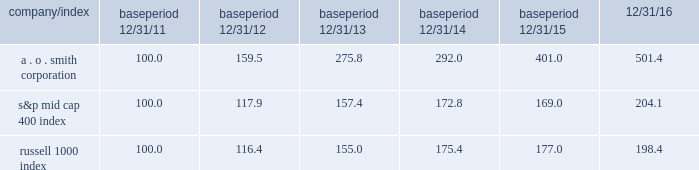The graph below shows a five-year comparison of the cumulative shareholder return on our common stock with the cumulative total return of the standard & poor 2019s ( s&p ) mid cap 400 index and the russell 1000 index , both of which are published indices .
Comparison of five-year cumulative total return from december 31 , 2011 to december 31 , 2016 assumes $ 100 invested with reinvestment of dividends period indexed returns .
2011 2012 2013 2014 2015 2016 smith ( a o ) corp s&p midcap 400 index russell 1000 index .
What was the difference in total return for the five year period ended 12/31/16 between a . o . smith corporation and the s&p mid cap 400 index? 
Computations: (((501.4 - 100) / 100) - ((204.1 - 100) / 100))
Answer: 2.973. 